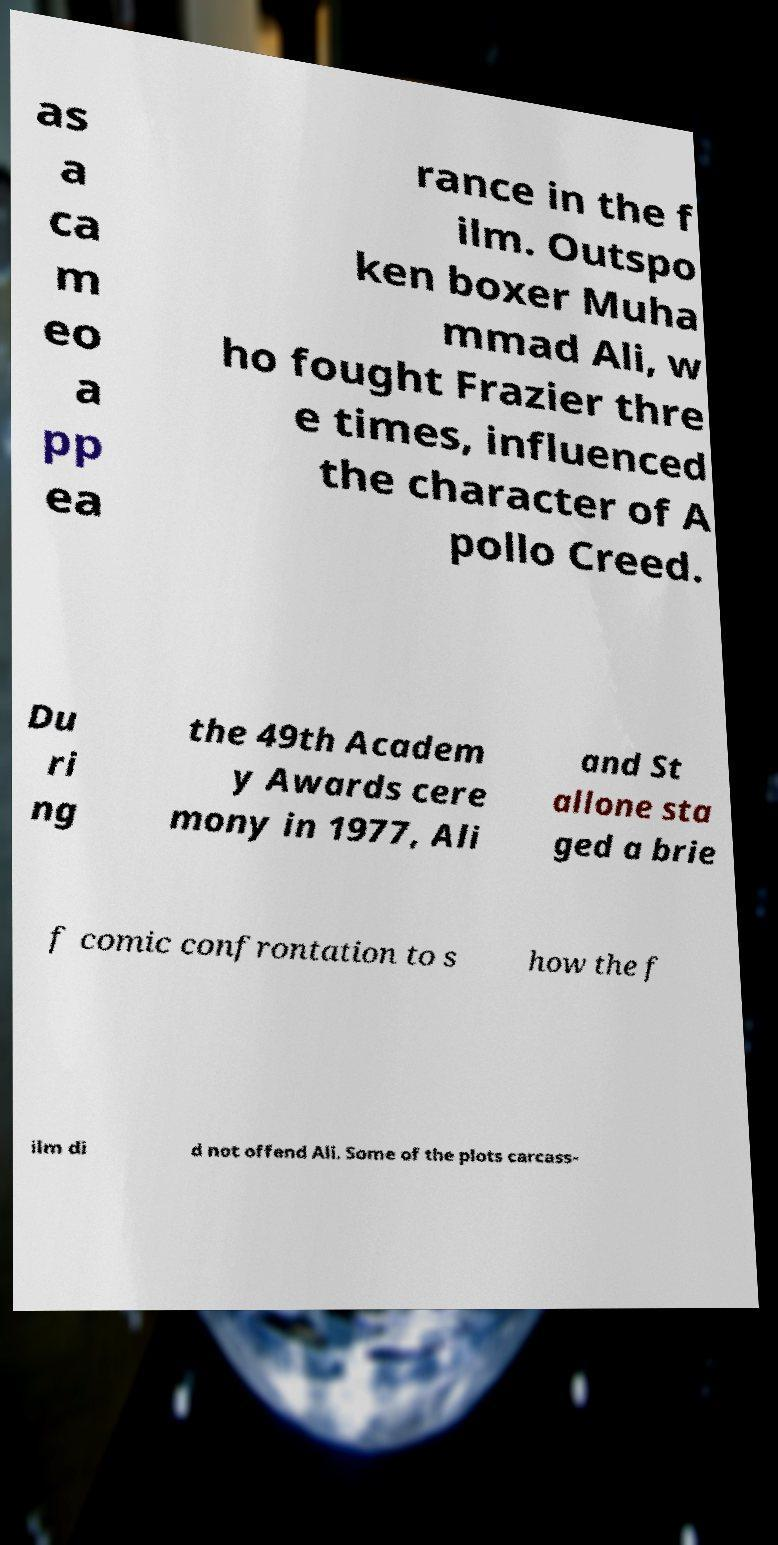There's text embedded in this image that I need extracted. Can you transcribe it verbatim? as a ca m eo a pp ea rance in the f ilm. Outspo ken boxer Muha mmad Ali, w ho fought Frazier thre e times, influenced the character of A pollo Creed. Du ri ng the 49th Academ y Awards cere mony in 1977, Ali and St allone sta ged a brie f comic confrontation to s how the f ilm di d not offend Ali. Some of the plots carcass- 